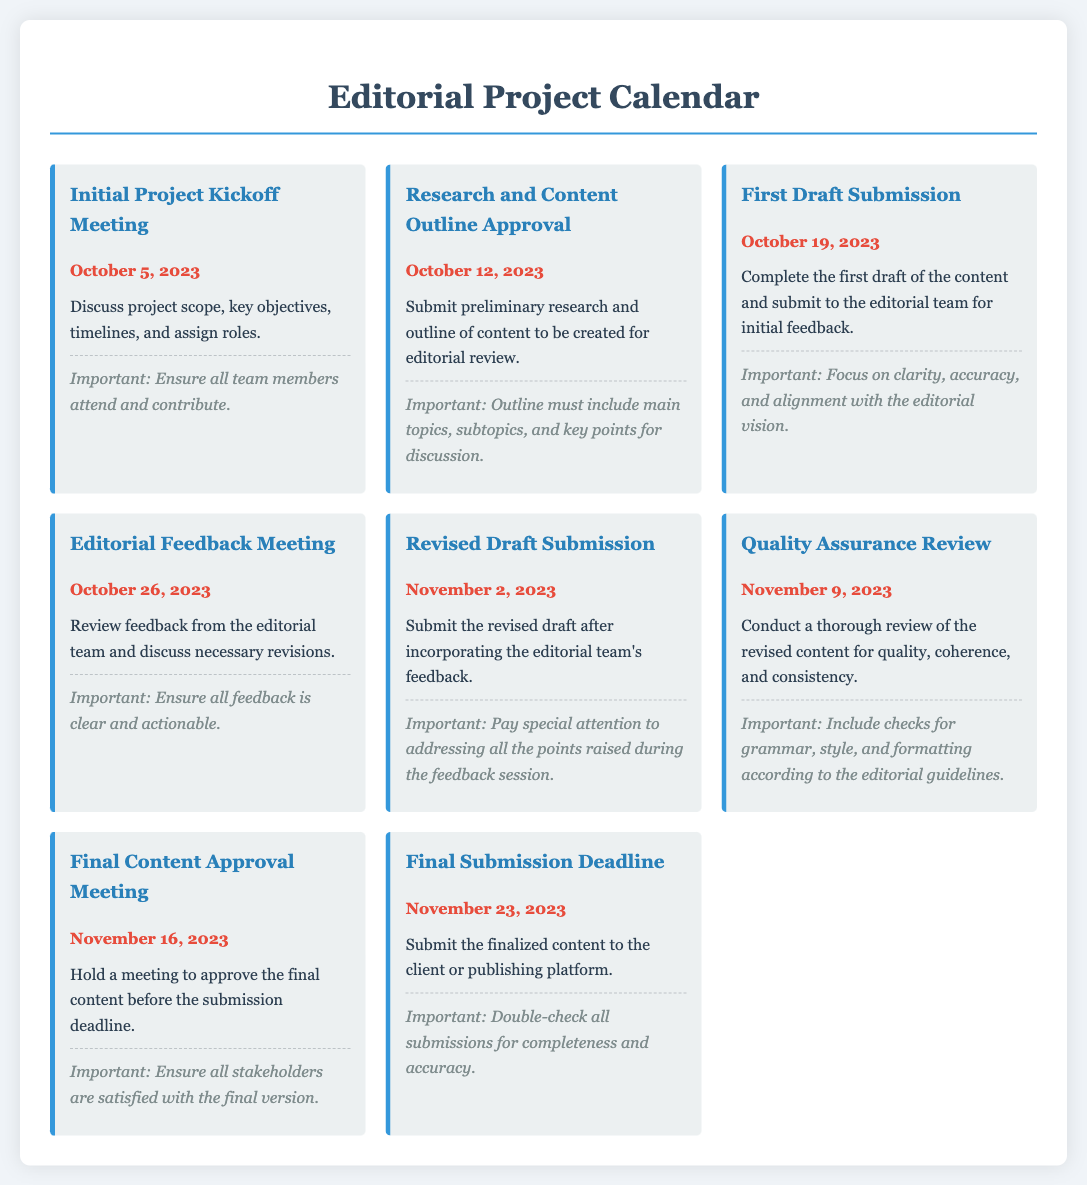what is the date of the Initial Project Kickoff Meeting? The date is specified in the document under the milestone section for the Initial Project Kickoff Meeting.
Answer: October 5, 2023 who is responsible for submitting the First Draft? The First Draft Submission milestone indicates that it is the responsibility of the content creator to submit the draft.
Answer: content creator what is the main focus during the First Draft Submission? The document specifies that during the First Draft Submission, the focus should be on clarity, accuracy, and alignment with the editorial vision.
Answer: clarity, accuracy, alignment what is the deadline for the Final Submission? The deadline is mentioned in the Final Submission Deadline milestone section.
Answer: November 23, 2023 how many days are there between the Research and Content Outline Approval and the First Draft Submission? The duration is calculated by examining the dates of the two milestones.
Answer: 7 days what type of meeting is scheduled on October 26, 2023? The meeting type is indicated in the milestone for that date, which specifies it as an Editorial Feedback Meeting.
Answer: Editorial Feedback Meeting what should the Revised Draft address? The notes for the Revised Draft Submission milestone state that it must address all points raised during the feedback session.
Answer: all points raised when is the Quality Assurance Review scheduled? The date for the Quality Assurance Review is found in the corresponding milestone section of the document.
Answer: November 9, 2023 what is the purpose of the Final Content Approval Meeting? The document outlines that this meeting is held to approve the final content before submission.
Answer: approve the final content 